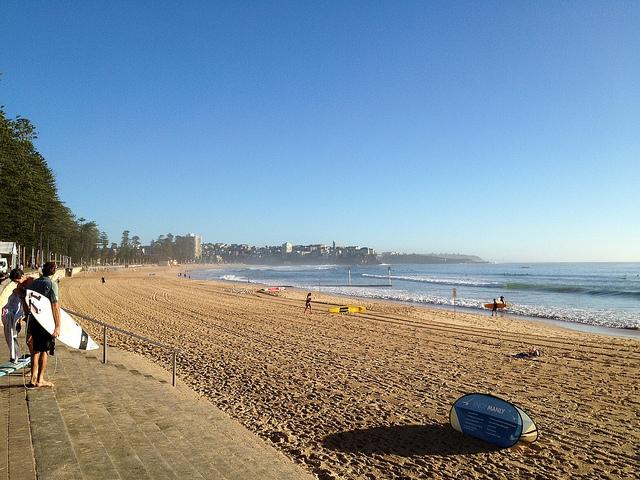Will someone push the surfers down the stairs?
Short answer required. No. Where is this beach located at?
Answer briefly. California. Is it low tide?
Short answer required. Yes. 